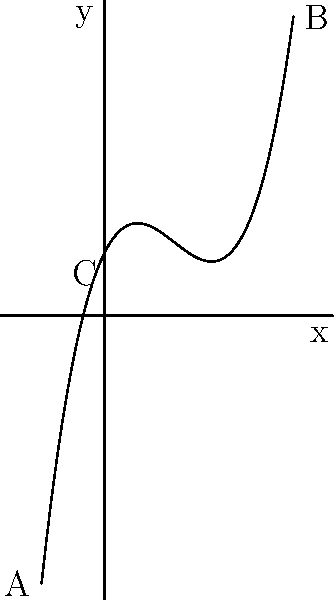As a game level designer, you want to create a visually appealing terrain using a polynomial curve. The curve is represented by the function $f(x) = 0.03x^3 - 0.5x^2 + 2x + 5$, where $x$ represents the horizontal distance and $f(x)$ represents the height. What is the maximum number of inflection points this curve can have in the interval $[-5, 15]$, and how does this affect the visual appeal of the game level? To determine the number of inflection points, we need to follow these steps:

1. Recall that inflection points occur where the second derivative of the function changes sign.

2. Find the first derivative of $f(x)$:
   $f'(x) = 0.09x^2 - x + 2$

3. Find the second derivative of $f(x)$:
   $f''(x) = 0.18x - 1$

4. Set the second derivative equal to zero and solve for x:
   $0.18x - 1 = 0$
   $0.18x = 1$
   $x = \frac{1}{0.18} \approx 5.56$

5. This x-value represents the only possible inflection point within the given interval $[-5, 15]$.

6. Verify that the second derivative changes sign at this point:
   For $x < 5.56$, $f''(x) < 0$
   For $x > 5.56$, $f''(x) > 0$

Therefore, there is exactly one inflection point in the given interval.

Regarding visual appeal:
- The inflection point creates a smooth transition between concave and convex sections of the terrain.
- This single inflection point allows for a gradual change in the landscape, providing a natural-looking and visually pleasing curve.
- It creates a balanced design with a gentle slope at the beginning, a steeper middle section, and a flattening out towards the end, which can be ideal for game level progression.
Answer: One inflection point, enhancing visual appeal through balanced terrain transitions. 